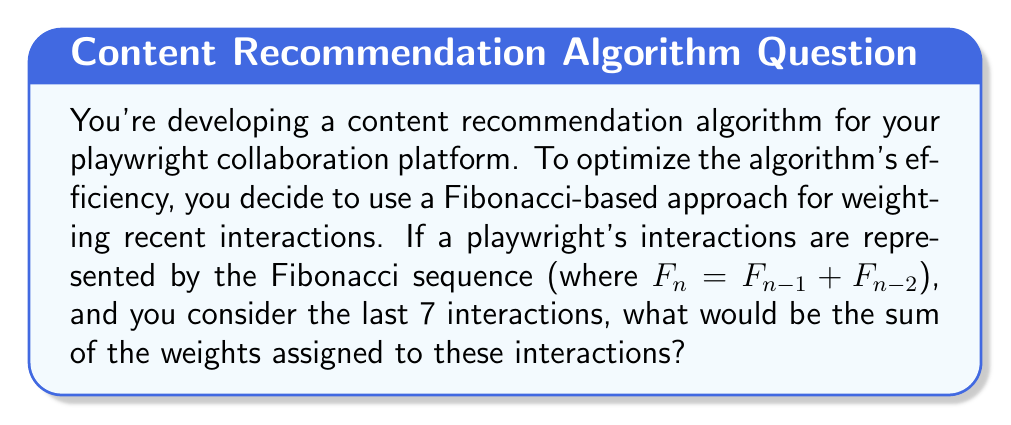Give your solution to this math problem. Let's approach this step-by-step:

1) First, recall the Fibonacci sequence: 1, 1, 2, 3, 5, 8, 13, ...

2) We need the last 7 terms of this sequence for our weights:
   $F_1 = 1$
   $F_2 = 1$
   $F_3 = 2$
   $F_4 = 3$
   $F_5 = 5$
   $F_6 = 8$
   $F_7 = 13$

3) The sum of these 7 terms will give us the total weight:

   $$\sum_{i=1}^7 F_i = F_1 + F_2 + F_3 + F_4 + F_5 + F_6 + F_7$$

4) Substituting the values:

   $$\sum_{i=1}^7 F_i = 1 + 1 + 2 + 3 + 5 + 8 + 13$$

5) Calculating the sum:

   $$\sum_{i=1}^7 F_i = 33$$

Therefore, the sum of the weights for the last 7 interactions is 33.
Answer: 33 